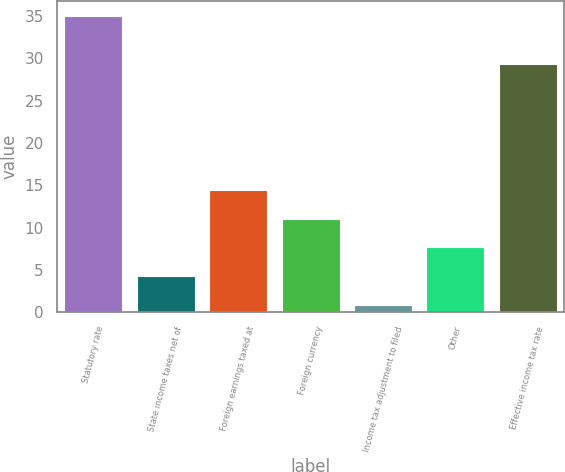Convert chart to OTSL. <chart><loc_0><loc_0><loc_500><loc_500><bar_chart><fcel>Statutory rate<fcel>State income taxes net of<fcel>Foreign earnings taxed at<fcel>Foreign currency<fcel>Income tax adjustment to filed<fcel>Other<fcel>Effective income tax rate<nl><fcel>35<fcel>4.22<fcel>14.48<fcel>11.06<fcel>0.8<fcel>7.64<fcel>29.3<nl></chart> 